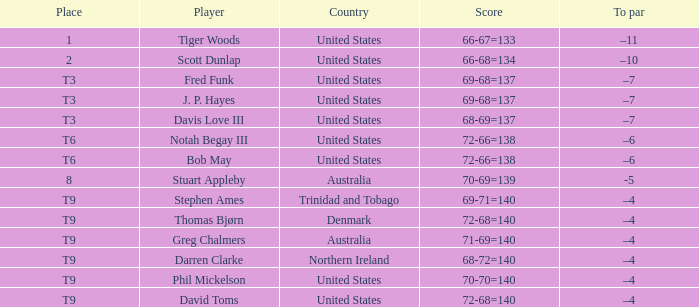What is the corresponding to par value for a score of 70-69=139? -5.0. 